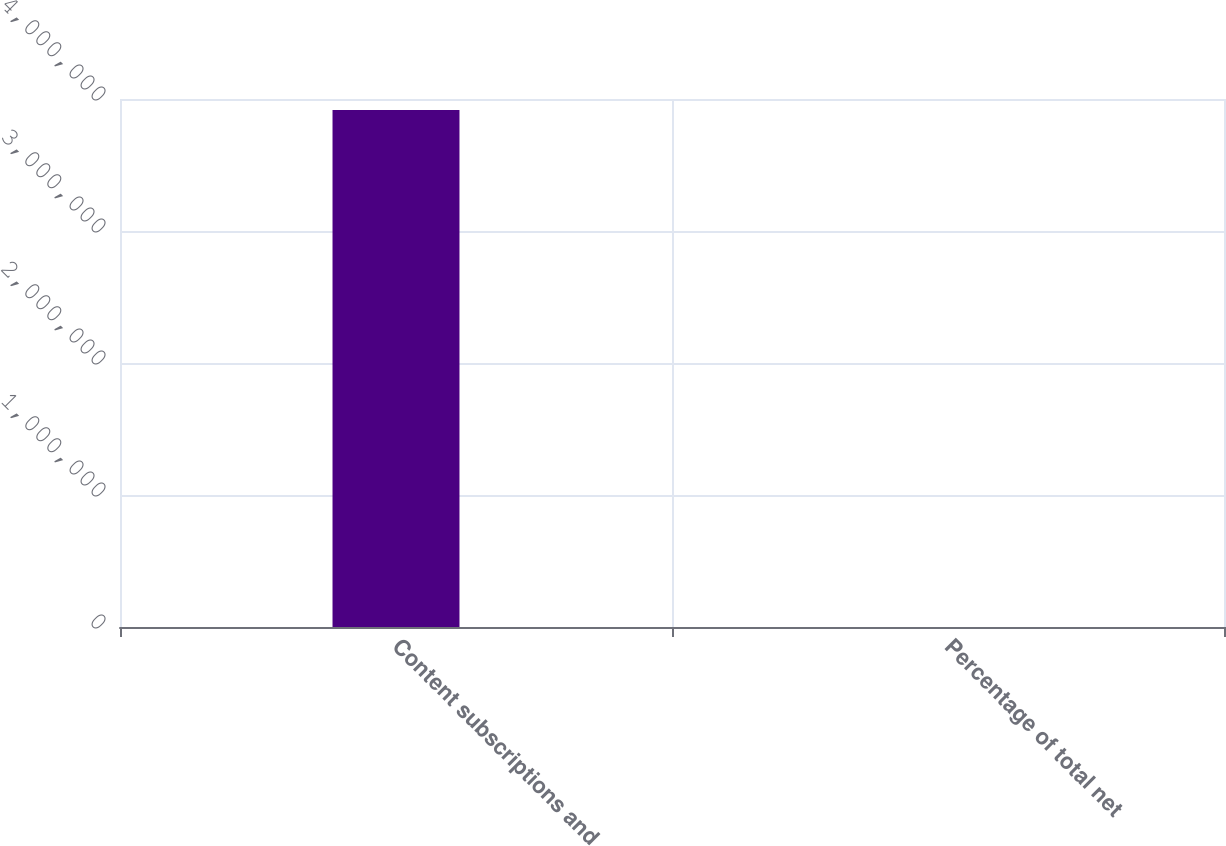Convert chart to OTSL. <chart><loc_0><loc_0><loc_500><loc_500><bar_chart><fcel>Content subscriptions and<fcel>Percentage of total net<nl><fcel>3.91757e+06<fcel>75<nl></chart> 